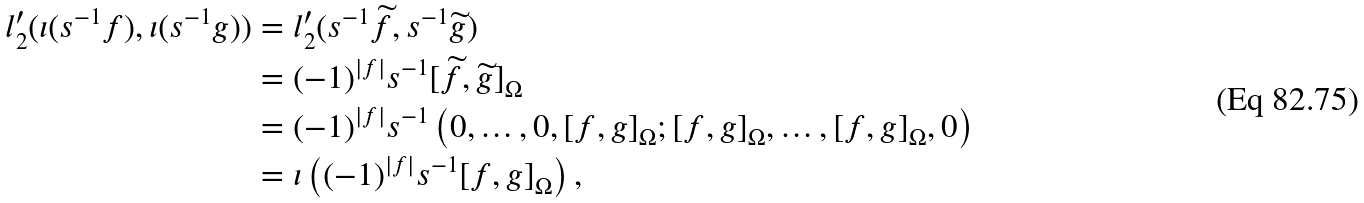<formula> <loc_0><loc_0><loc_500><loc_500>l _ { 2 } ^ { \prime } ( \iota ( s ^ { - 1 } f ) , \iota ( s ^ { - 1 } g ) ) & = l _ { 2 } ^ { \prime } ( s ^ { - 1 } \widetilde { f } , s ^ { - 1 } \widetilde { g } ) \\ & = ( - 1 ) ^ { | f | } s ^ { - 1 } [ \widetilde { f } , \widetilde { g } ] _ { \Omega } \\ & = ( - 1 ) ^ { | f | } s ^ { - 1 } \left ( 0 , \dots , 0 , [ f , g ] _ { \Omega } ; [ f , g ] _ { \Omega } , \dots , [ f , g ] _ { \Omega } , 0 \right ) \\ & = \iota \left ( ( - 1 ) ^ { | f | } s ^ { - 1 } [ f , g ] _ { \Omega } \right ) ,</formula> 